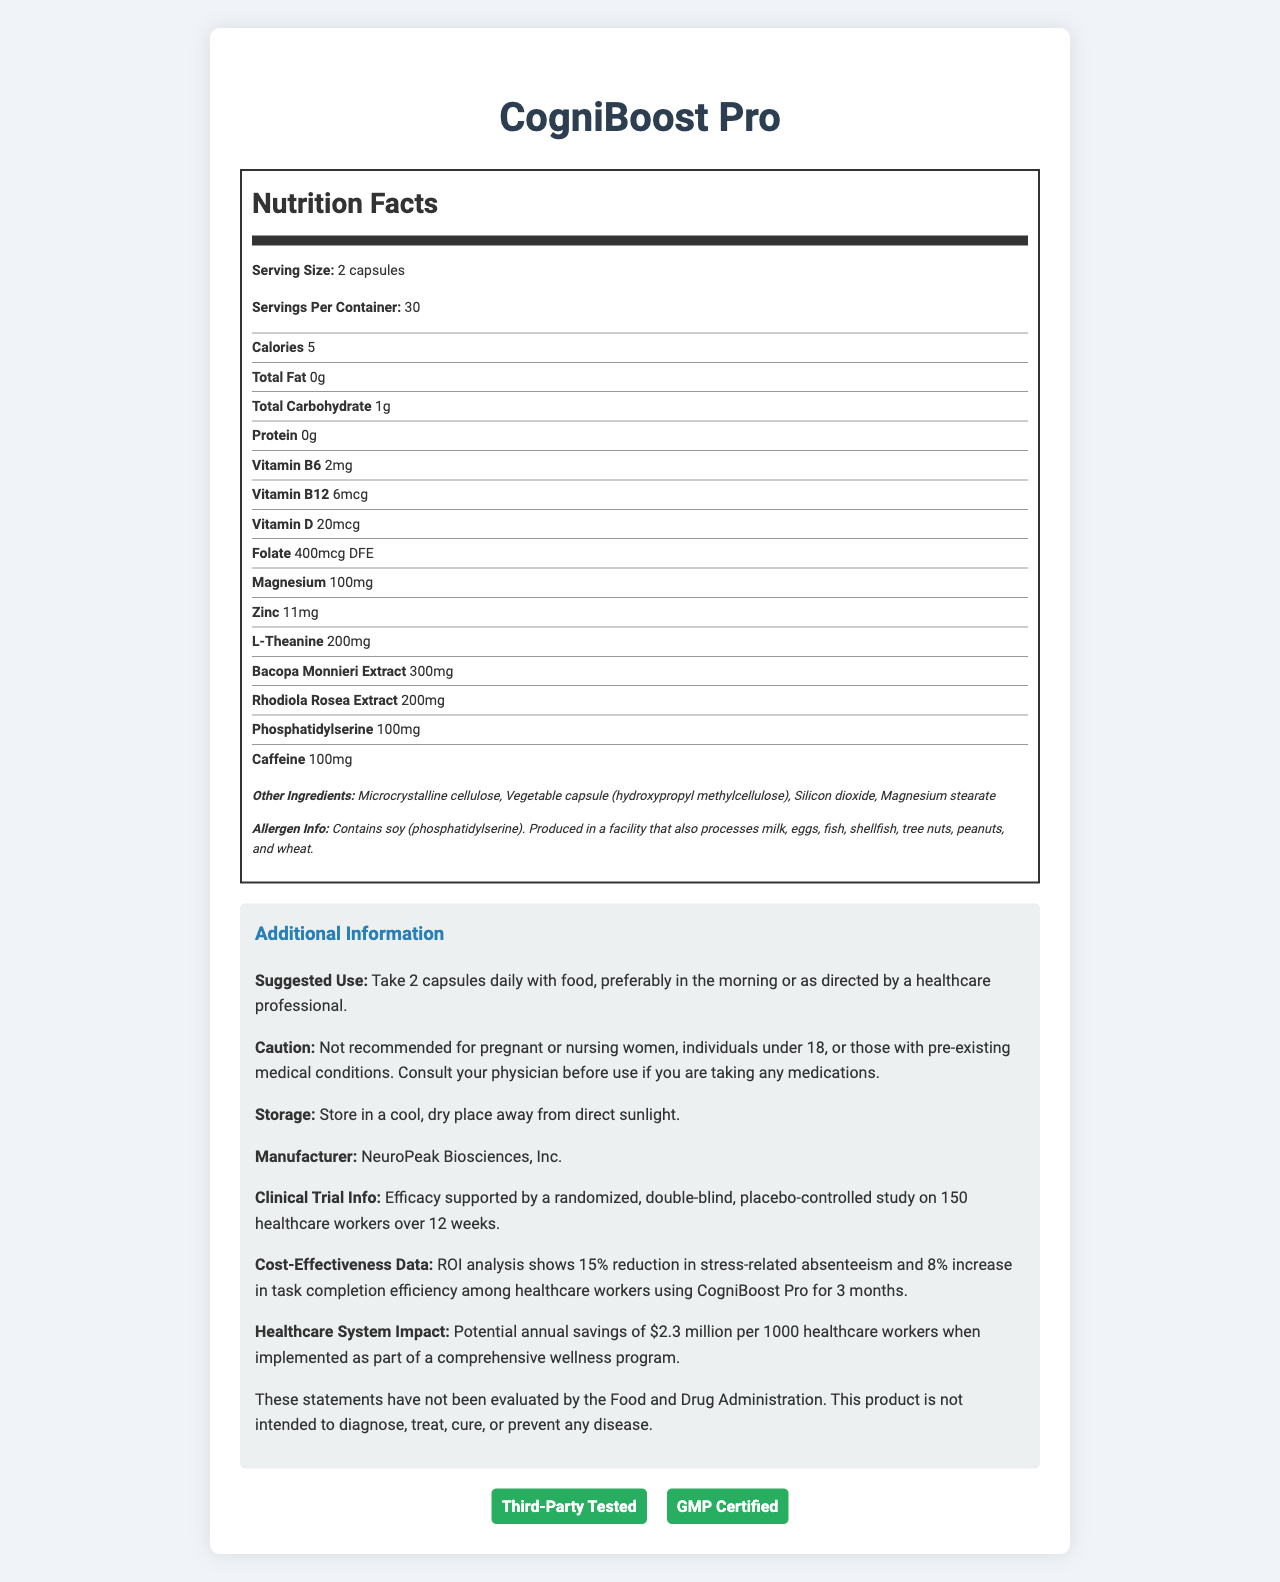What is the serving size for CogniBoost Pro? The serving size listed on the document is "2 capsules."
Answer: 2 capsules How many servings does each container of CogniBoost Pro have? The document states there are 30 servings per container.
Answer: 30 What is the amount of caffeine per serving in CogniBoost Pro? The amount of caffeine is listed in the document as 100mg.
Answer: 100mg Name two vitamins that are included in CogniBoost Pro and their amounts. The document lists Vitamin B6 as 2mg and Vitamin B12 as 6mcg.
Answer: Vitamin B6 (2mg), Vitamin B12 (6mcg) What are the main herbal extracts included in CogniBoost Pro? The document specifies Bacopa Monnieri Extract (300mg) and Rhodiola Rosea Extract (200mg).
Answer: Bacopa Monnieri Extract (300mg), Rhodiola Rosea Extract (200mg) What is the recommended daily use for CogniBoost Pro? The suggested use section of the document mentions to take 2 capsules daily with food, preferably in the morning or as directed by a healthcare professional.
Answer: Take 2 capsules daily with food, preferably in the morning or as directed by a healthcare professional. Which of the following is NOT an ingredient in CogniBoost Pro? A. Silicon Dioxide B. Taurine C. Magnesium Stearate D. Microcrystalline Cellulose The other ingredients section lists Silicon Dioxide, Magnesium Stearate, and Microcrystalline Cellulose but not Taurine.
Answer: B How is CogniBoost Pro tested and certified? A. FDA Approved B. GMP Certified C. Third-Party Tested D. Both B and C The document mentions that CogniBoost Pro is GMP certified and third-party tested.
Answer: D Does CogniBoost Pro contain any allergens? The document indicates that CogniBoost Pro contains soy and is produced in a facility that processes other allergens.
Answer: Yes Is CogniBoost Pro recommended for pregnant women? The caution section clearly states that it is not recommended for pregnant or nursing women.
Answer: No What is the potential annual savings for healthcare systems when implementing CogniBoost Pro? The healthcare system impact section notes potential annual savings of $2.3 million per 1000 healthcare workers.
Answer: $2.3 million per 1000 healthcare workers Summarize the main idea of the document. The document contains comprehensive information about the dietary supplement including its ingredients, usage recommendations, safety information, and potential benefits supported by clinical trials.
Answer: The document provides detailed nutritional information about the dietary supplement CogniBoost Pro, which is marketed to improve healthcare workers' cognitive performance and stress resilience. The document includes serving size, ingredient list, suggested use, storage instructions, allergen information, and details about clinical trials and potential healthcare system impact. It also mentions that the product is third-party tested and GMP certified. What is the clinical trial study size mentioned in the document? The clinical trial info section states that the study involved 150 healthcare workers.
Answer: 150 healthcare workers What is the ROI analysis finding for CogniBoost Pro's cost-effectiveness? The cost-effectiveness data section of the document mentions a 15% reduction in stress-related absenteeism and an 8% increase in task completion efficiency.
Answer: 15% reduction in stress-related absenteeism and 8% increase in task completion efficiency What is the deficiency of information for determining CogniBoost Pro’s long-term effects? The document does not provide data on the long-term effects of using CogniBoost Pro.
Answer: Not enough information 